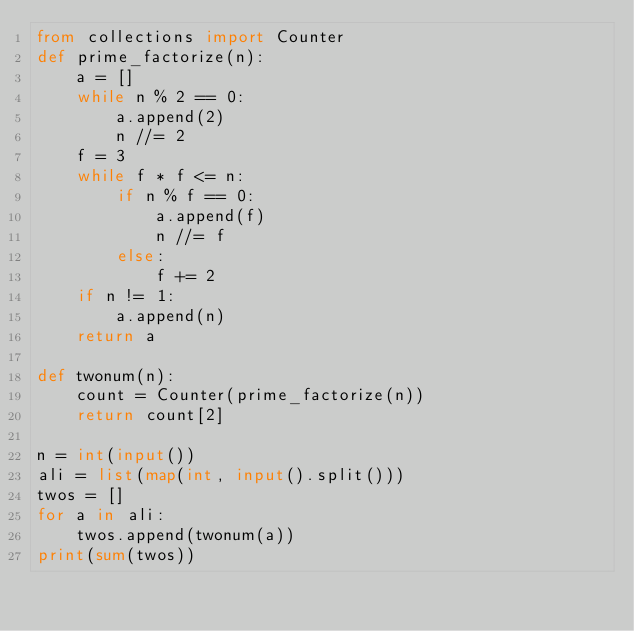Convert code to text. <code><loc_0><loc_0><loc_500><loc_500><_Python_>from collections import Counter
def prime_factorize(n):
    a = []
    while n % 2 == 0:
        a.append(2)
        n //= 2
    f = 3
    while f * f <= n:
        if n % f == 0:
            a.append(f)
            n //= f
        else:
            f += 2
    if n != 1:
        a.append(n)
    return a

def twonum(n):
    count = Counter(prime_factorize(n))
    return count[2]

n = int(input())
ali = list(map(int, input().split()))
twos = []
for a in ali:
    twos.append(twonum(a))
print(sum(twos))</code> 